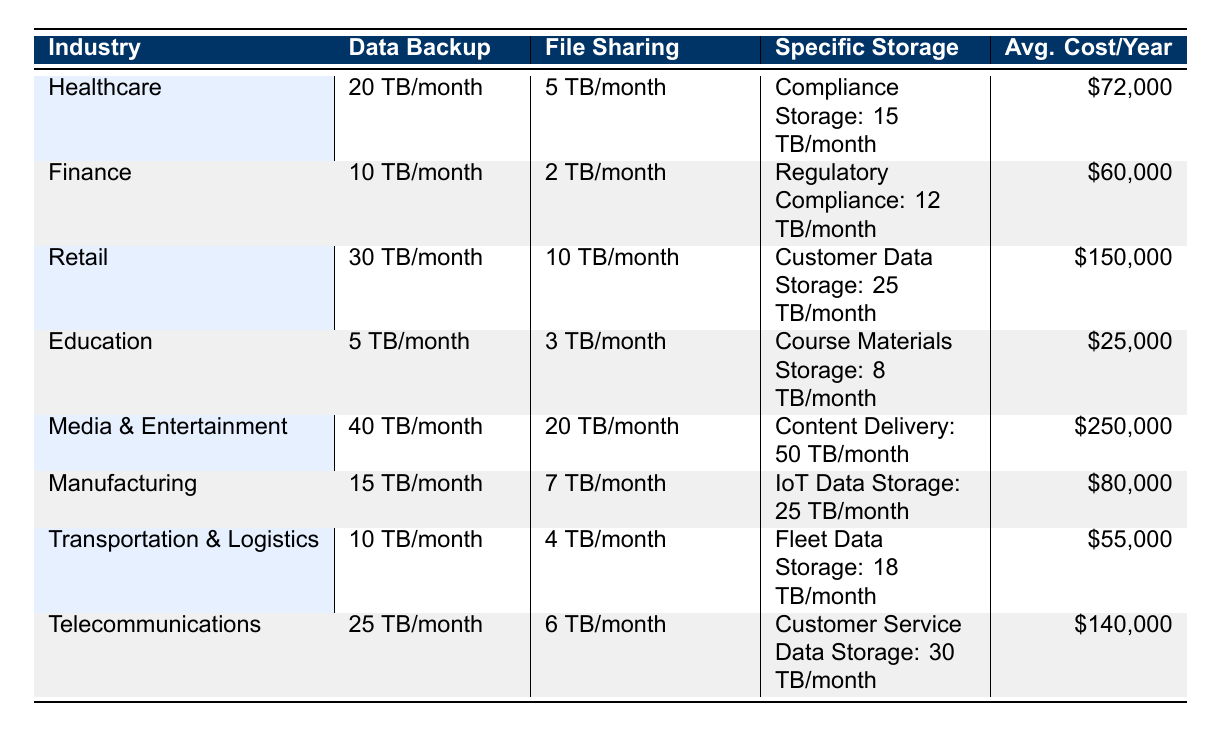What is the average cost per year for the Healthcare industry? The average cost per year for the Healthcare industry is listed directly in the table under the "Avg. Cost/Year" column for that industry. The value is $72,000.
Answer: $72,000 Which industry has the highest Data Backup usage? Reviewing the "Data Backup" column in the table, the Media & Entertainment industry has the highest usage at 40 TB/month.
Answer: Media & Entertainment Do Telecommunications spend more on cloud storage services than Finance? Comparing the "Avg. Cost/Year" values in the table, Telecommunications have an average cost of $140,000 while Finance has an average cost of $60,000, indicating Telecommunications spend more.
Answer: Yes What is the total Data Backup usage for Retail and Manufacturing combined? The Data Backup for Retail is 30 TB/month and for Manufacturing, it is 15 TB/month. Adding these together gives 30 + 15 = 45 TB/month as the total Data Backup usage.
Answer: 45 TB/month Which service usage is higher for the Education sector, File Sharing or Course Materials Storage? According to the table, the File Sharing usage is 3 TB/month while Course Materials Storage is 8 TB/month. Since 8 TB/month is greater than 3 TB/month, Course Materials Storage is higher.
Answer: Course Materials Storage What are the key vendors for the Media & Entertainment industry? The key vendors for Media & Entertainment are listed in the table under the "Key Vendors" column, which are Akamai, Amazon S3, and Microsoft Azure.
Answer: Akamai, Amazon S3, Microsoft Azure Is the total cost of cloud services for the Retail industry more than the sum of the costs for Healthcare and Education? The average cost for Retail is $150,000, for Healthcare is $72,000, and for Education is $25,000. Summing Healthcare and Education gives $72,000 + $25,000 = $97,000. Since $150,000 is greater than $97,000, the Retail cost is indeed more.
Answer: Yes How much more Data Backup is used in the Telecommunications sector compared to Finance? The Data Backup for Telecommunications is 25 TB/month, and Finance uses 10 TB/month. Subtracting Finance from Telecommunications gives 25 - 10 = 15 TB/month more usage in Telecommunications.
Answer: 15 TB/month Which industry has the lowest overall cost per year, and what is that cost? Evaluating the "Avg. Cost/Year" values, Education stands out with the lowest cost at $25,000, compared to all other industries.
Answer: Education; $25,000 